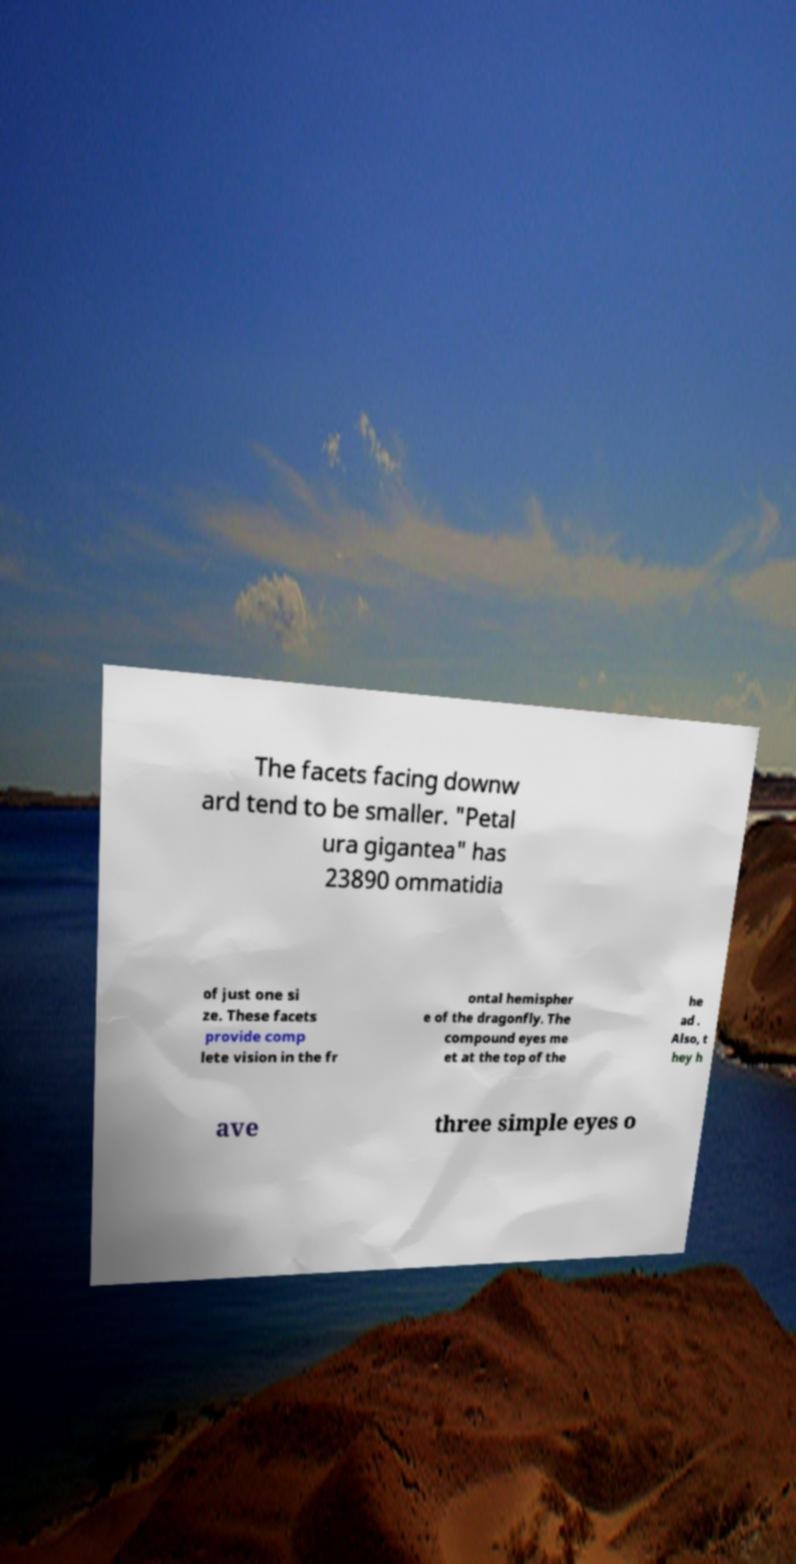I need the written content from this picture converted into text. Can you do that? The facets facing downw ard tend to be smaller. "Petal ura gigantea" has 23890 ommatidia of just one si ze. These facets provide comp lete vision in the fr ontal hemispher e of the dragonfly. The compound eyes me et at the top of the he ad . Also, t hey h ave three simple eyes o 